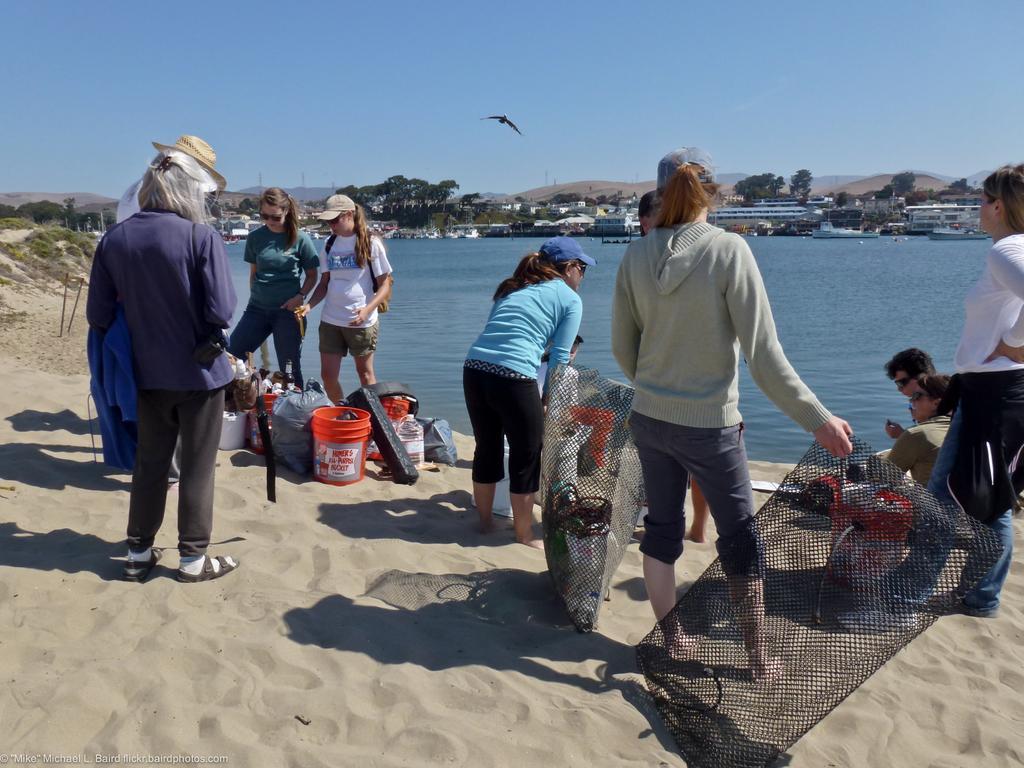Please provide a concise description of this image. There are persons in different color dresses, some of them are standing and remaining are sitting on the sand surface near water of the river. In the background, there is a bird flying in the air, there are boats on the water, there are buildings, trees and there is blue sky. 